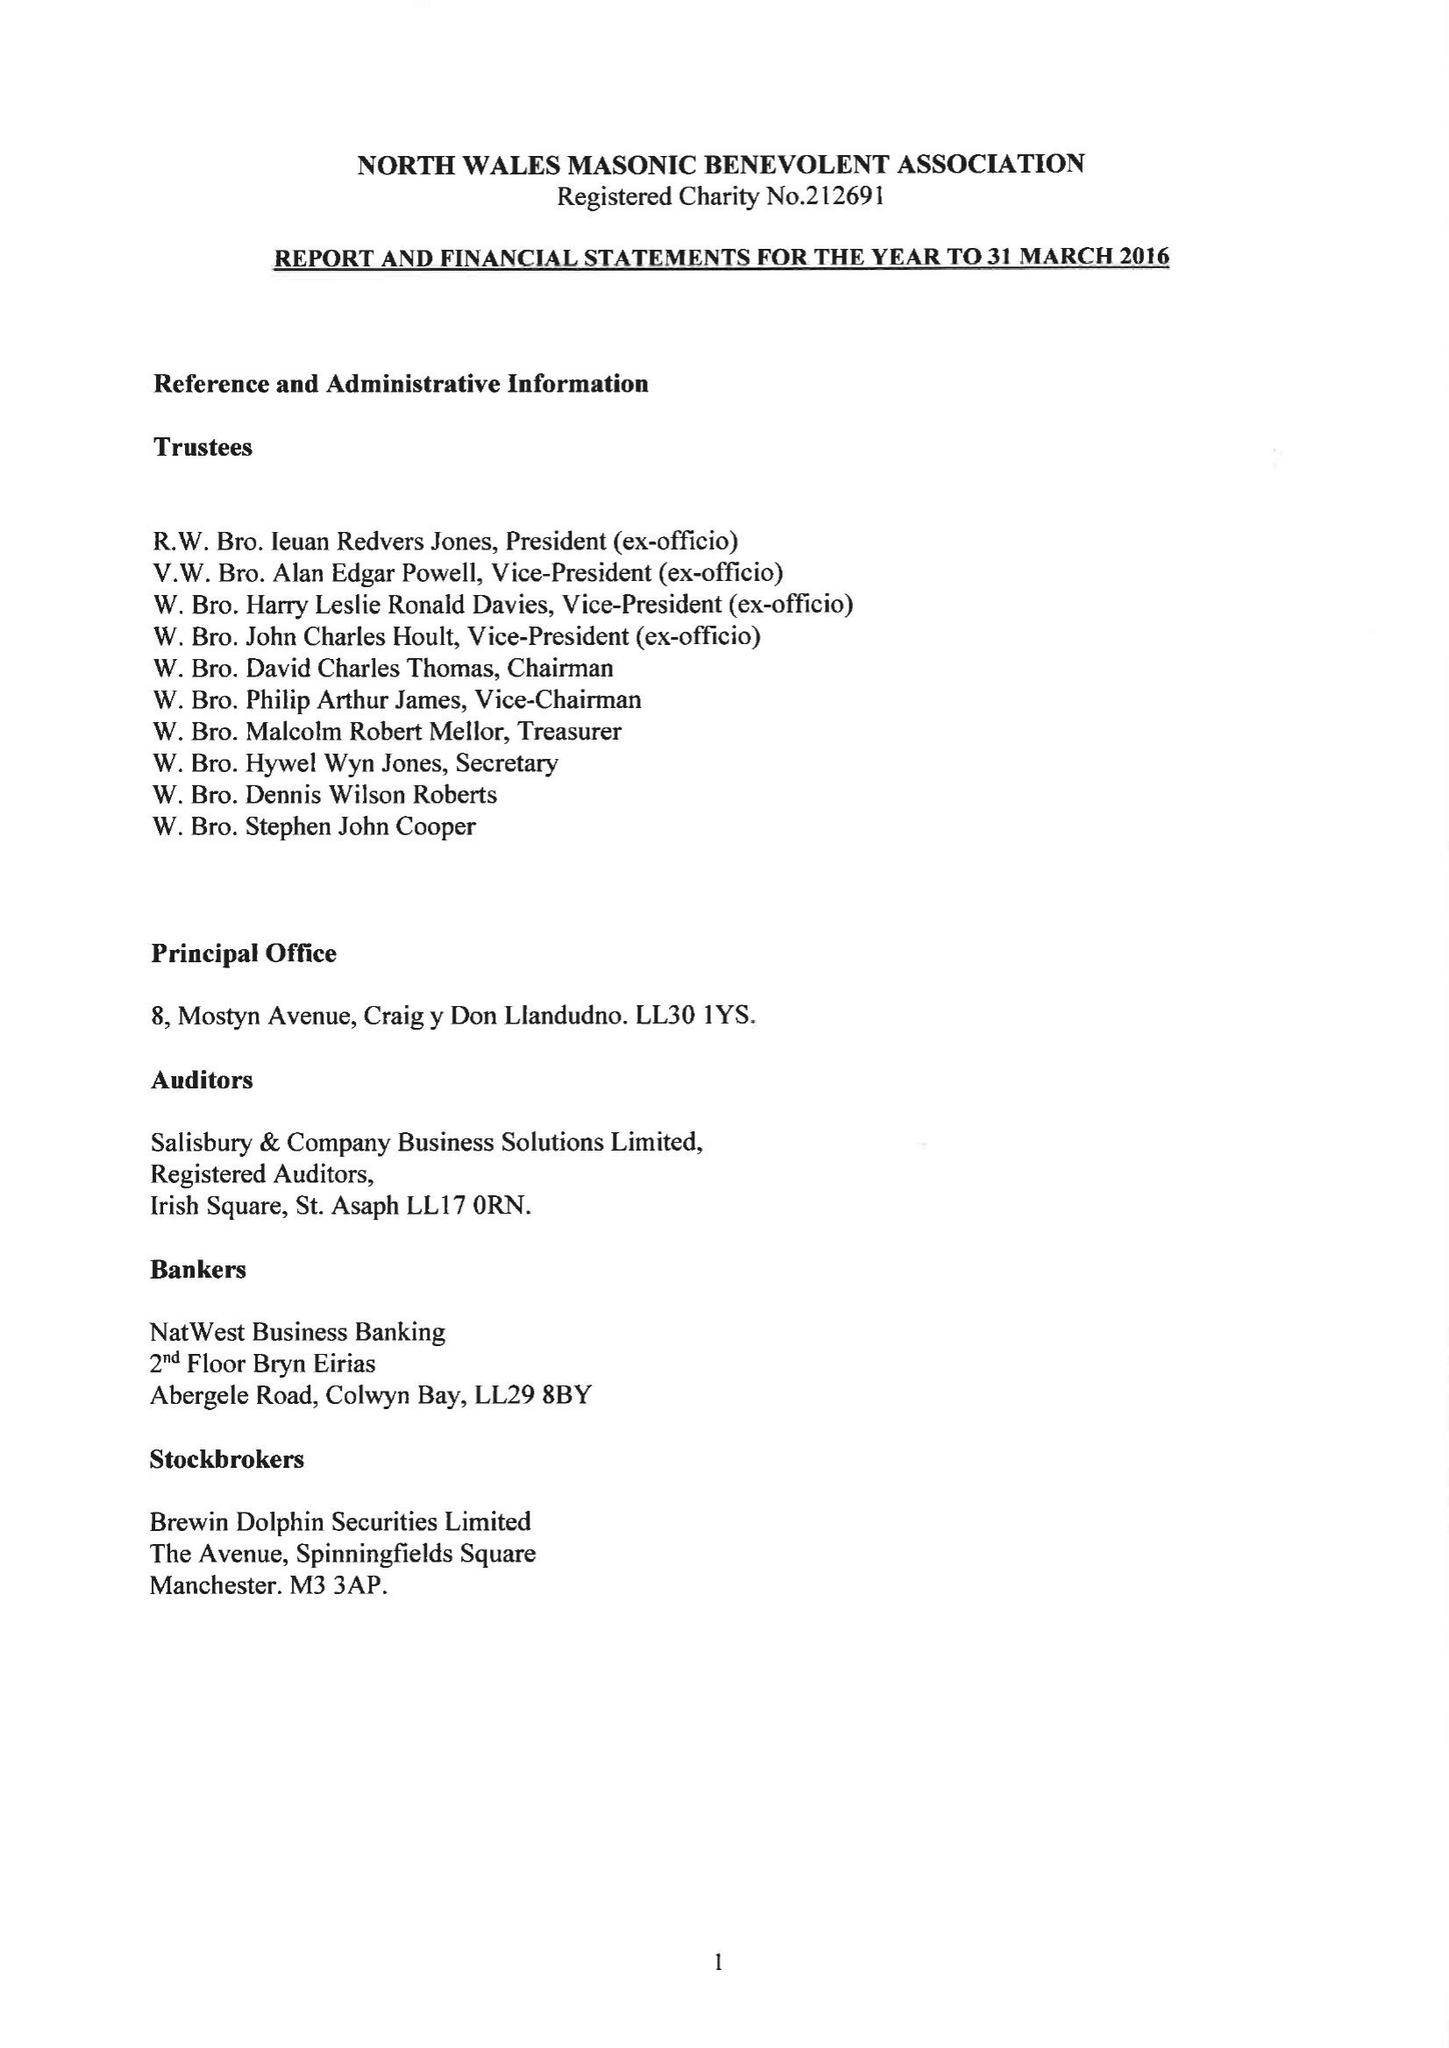What is the value for the report_date?
Answer the question using a single word or phrase. 2016-03-31 